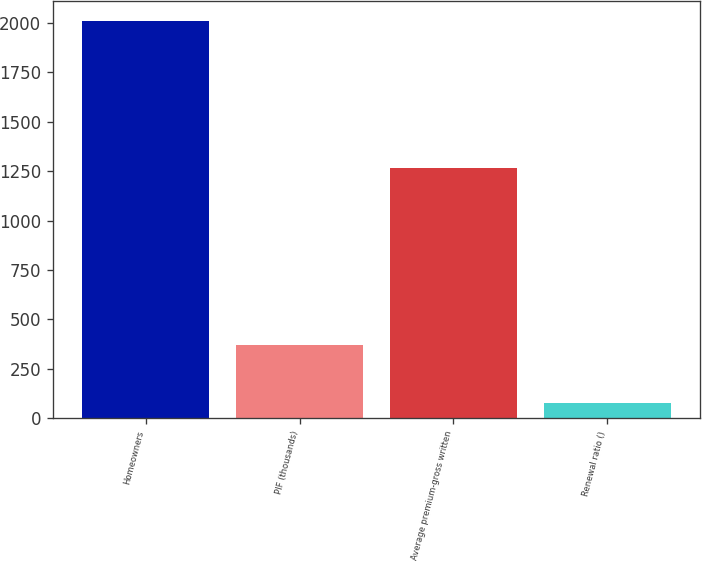<chart> <loc_0><loc_0><loc_500><loc_500><bar_chart><fcel>Homeowners<fcel>PIF (thousands)<fcel>Average premium-gross written<fcel>Renewal ratio ()<nl><fcel>2009<fcel>371<fcel>1265<fcel>78.9<nl></chart> 